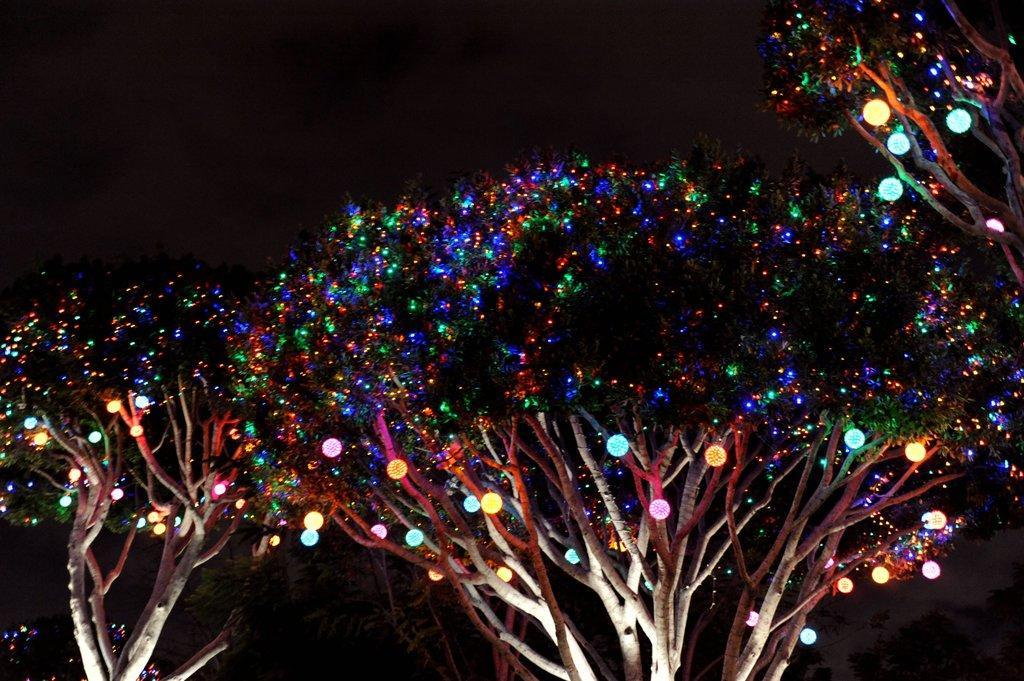Describe this image in one or two sentences. In this image we can see some trees with decorative lights and the background it is dark. 